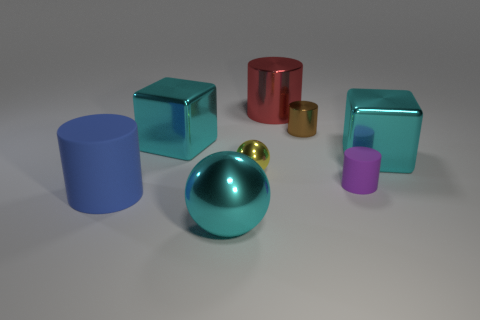Subtract all cyan cubes. How many were subtracted if there are1cyan cubes left? 1 Subtract 1 cylinders. How many cylinders are left? 3 Add 1 metal cubes. How many objects exist? 9 Subtract all spheres. How many objects are left? 6 Subtract 0 purple blocks. How many objects are left? 8 Subtract all tiny spheres. Subtract all purple matte cylinders. How many objects are left? 6 Add 5 big metallic blocks. How many big metallic blocks are left? 7 Add 4 large purple rubber blocks. How many large purple rubber blocks exist? 4 